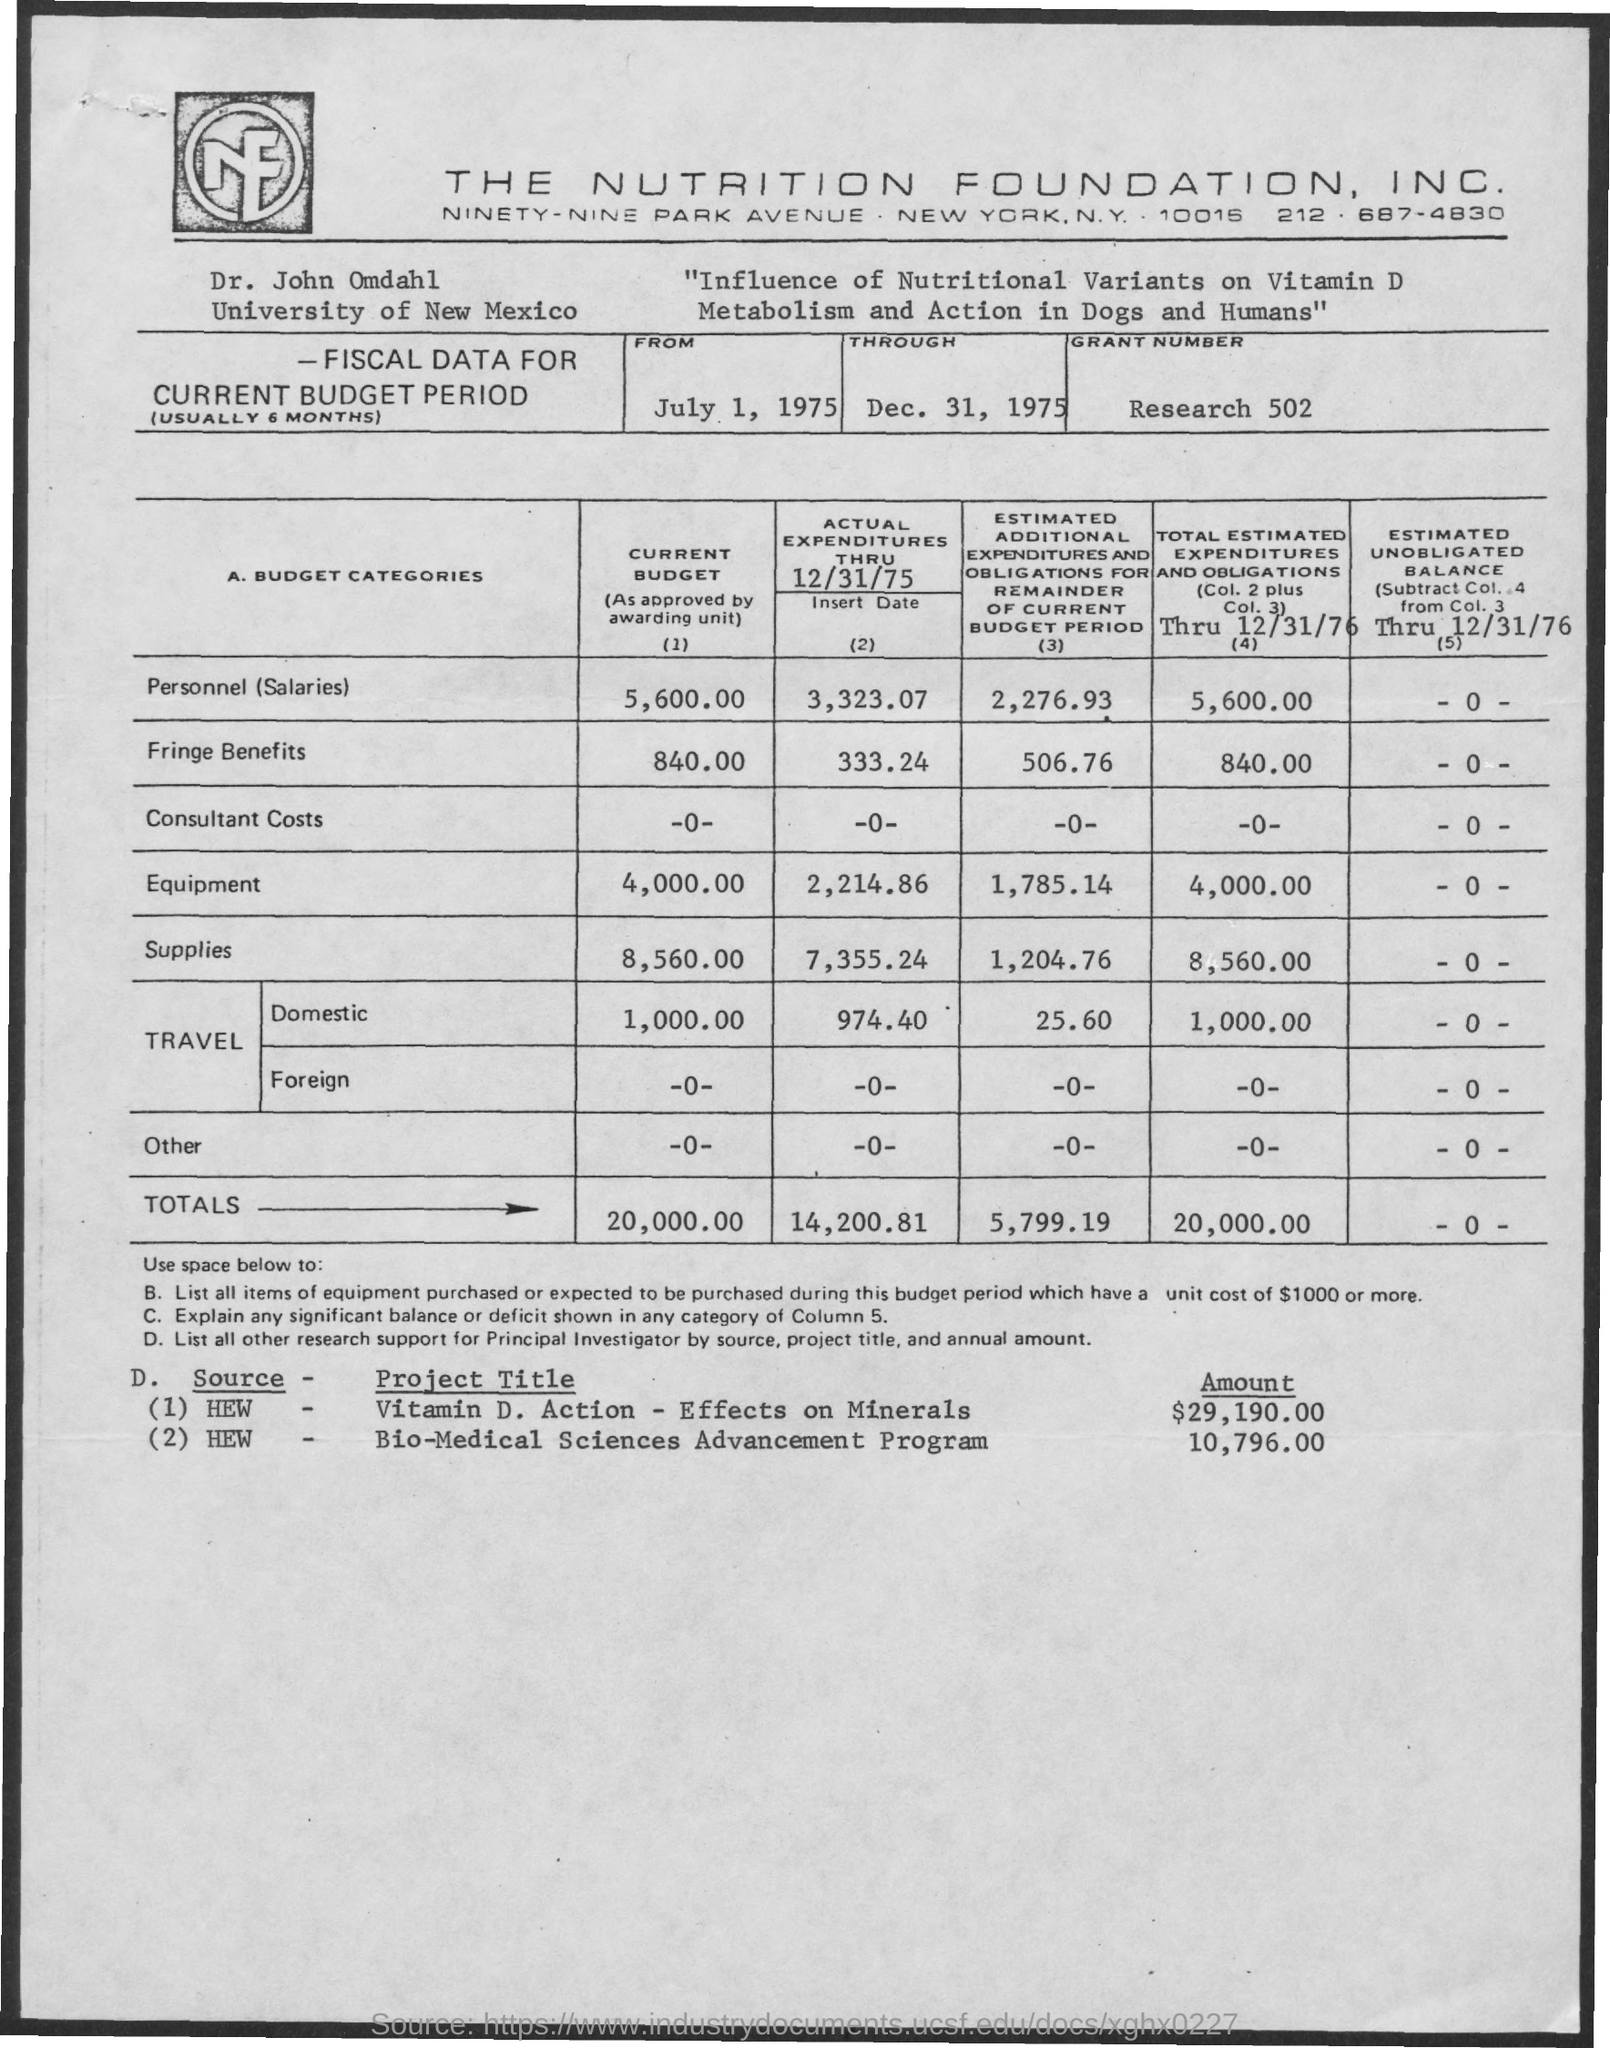Which firm is mentioned at the top of the page?
Keep it short and to the point. THE NUTRITION FOUNDATION, INC. What is the research about?
Your answer should be compact. "Influence of Nutritional Variants on Vitamin D Metabolism and Action in Dogs and Humans". What is the grant number?
Offer a terse response. Research 502. Who is the researcher?
Provide a short and direct response. Dr. John Omdahl. Which University is Dr. John Omdahl part of?
Your answer should be very brief. University of New Mexico. 